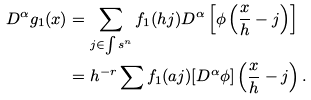Convert formula to latex. <formula><loc_0><loc_0><loc_500><loc_500>D ^ { \alpha } g _ { 1 } ( x ) & = \sum _ { j \in { \int s ^ { n } } } f _ { 1 } ( h j ) D ^ { \alpha } \left [ \phi \left ( \frac { x } h - j \right ) \right ] \\ & = h ^ { - r } \sum f _ { 1 } ( a j ) [ D ^ { \alpha } \phi ] \left ( \frac { x } h - j \right ) .</formula> 